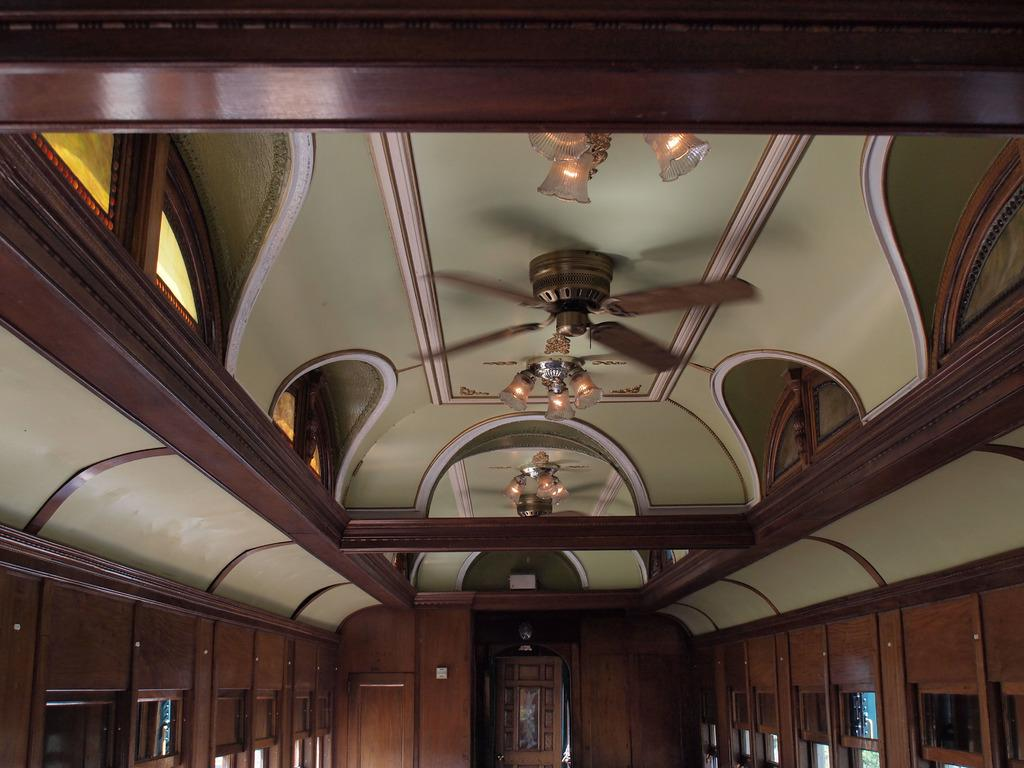What type of lighting is present in the image? There are ceiling lights in the image. What other fixture can be seen in the image? There is a fan in the image. What material is used for the ceiling in the image? The ceiling has wooden walls. How many clovers are growing on the ceiling in the image? There are no clovers present in the image; the ceiling has wooden walls. What type of organization is responsible for maintaining the fan in the image? There is no information about an organization responsible for maintaining the fan in the image. 